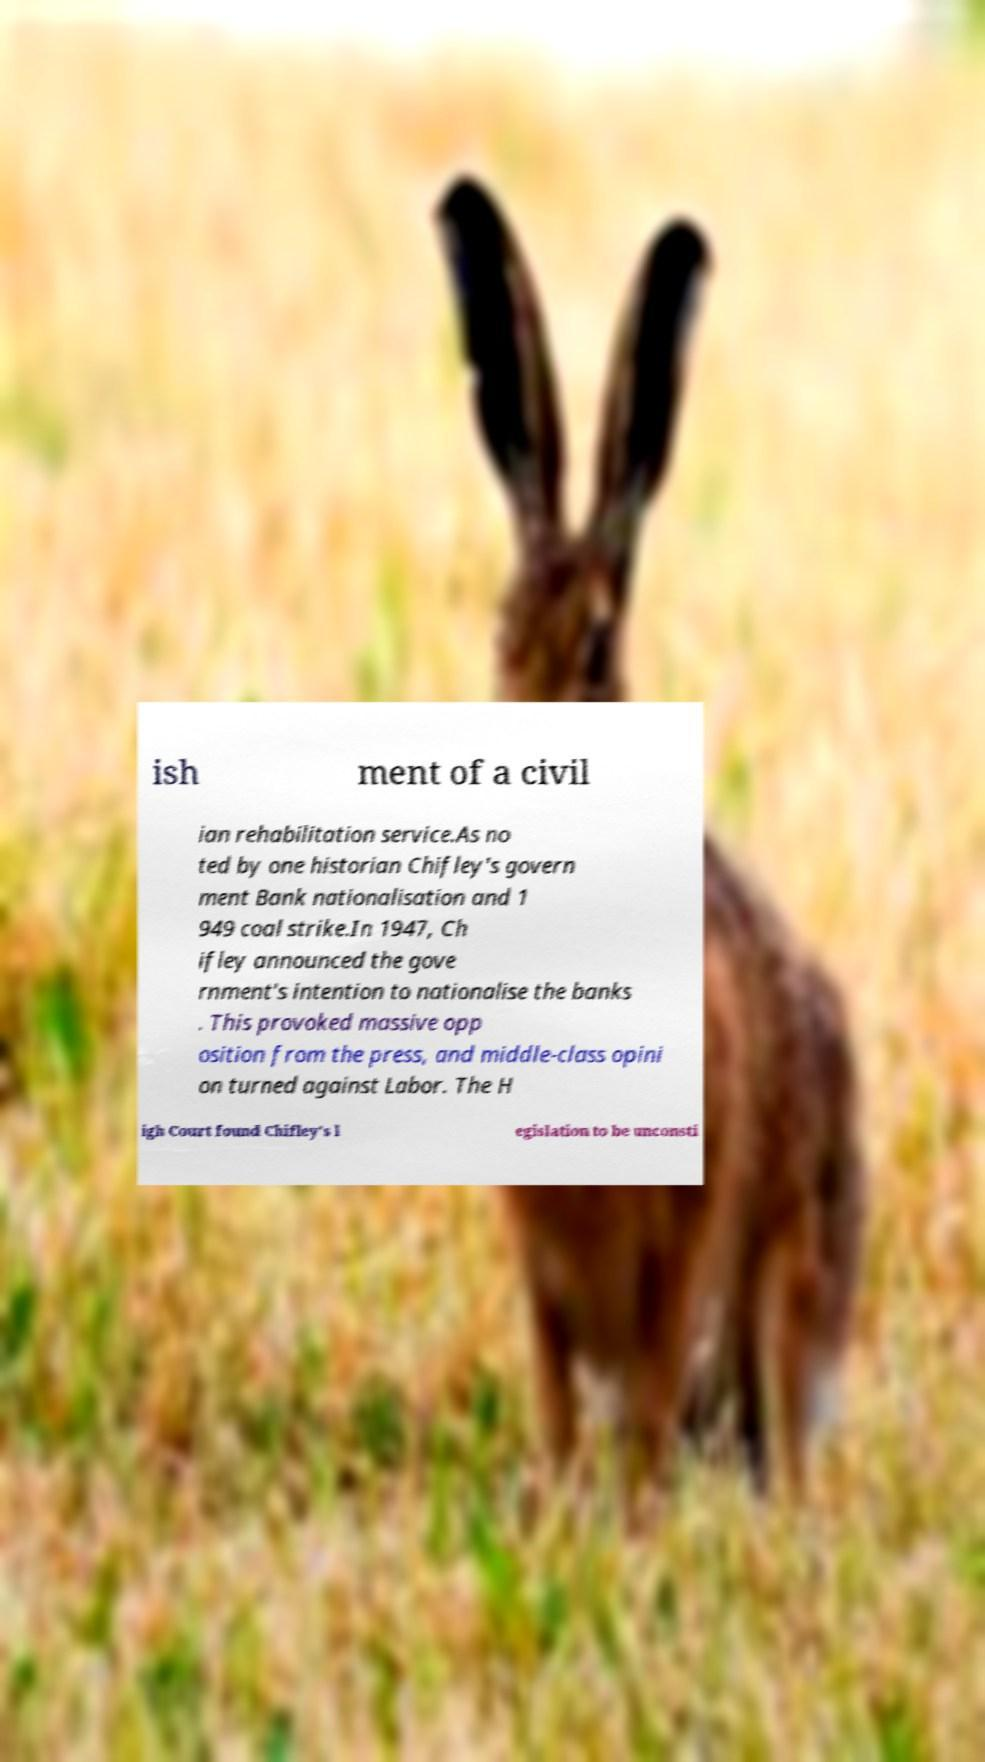Could you assist in decoding the text presented in this image and type it out clearly? ish ment of a civil ian rehabilitation service.As no ted by one historian Chifley's govern ment Bank nationalisation and 1 949 coal strike.In 1947, Ch ifley announced the gove rnment's intention to nationalise the banks . This provoked massive opp osition from the press, and middle-class opini on turned against Labor. The H igh Court found Chifley's l egislation to be unconsti 